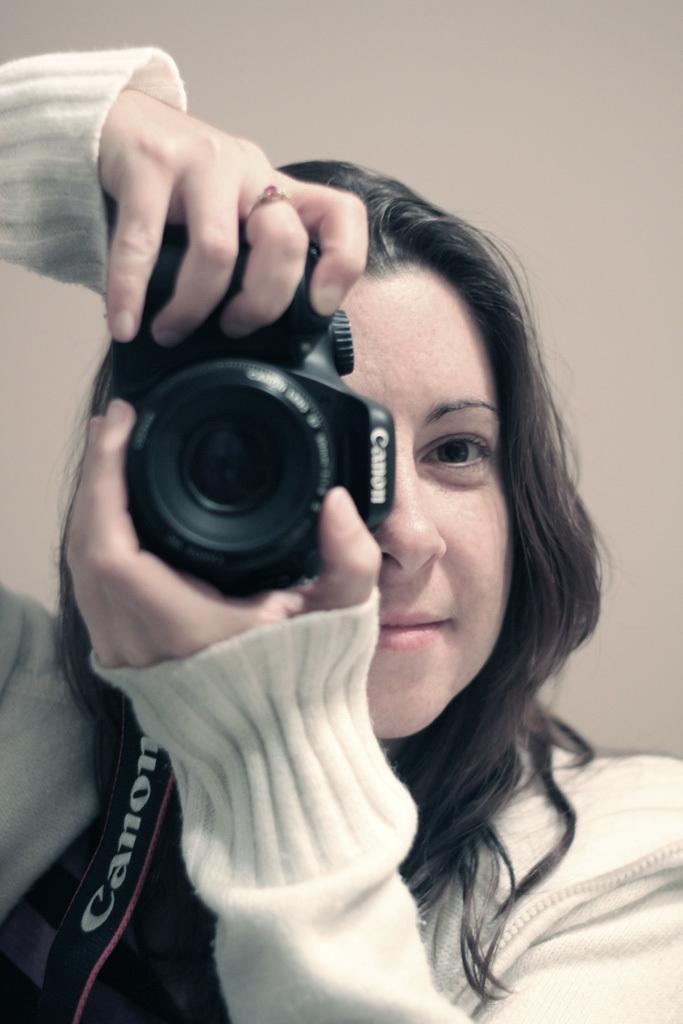In one or two sentences, can you explain what this image depicts? In the picture we can see a woman with a white color sweater and she is holding a camera and capturing something, the camera is black in color and behind her we can see a cream color surface wall. 